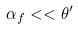<formula> <loc_0><loc_0><loc_500><loc_500>\alpha _ { f } < < \theta ^ { \prime }</formula> 